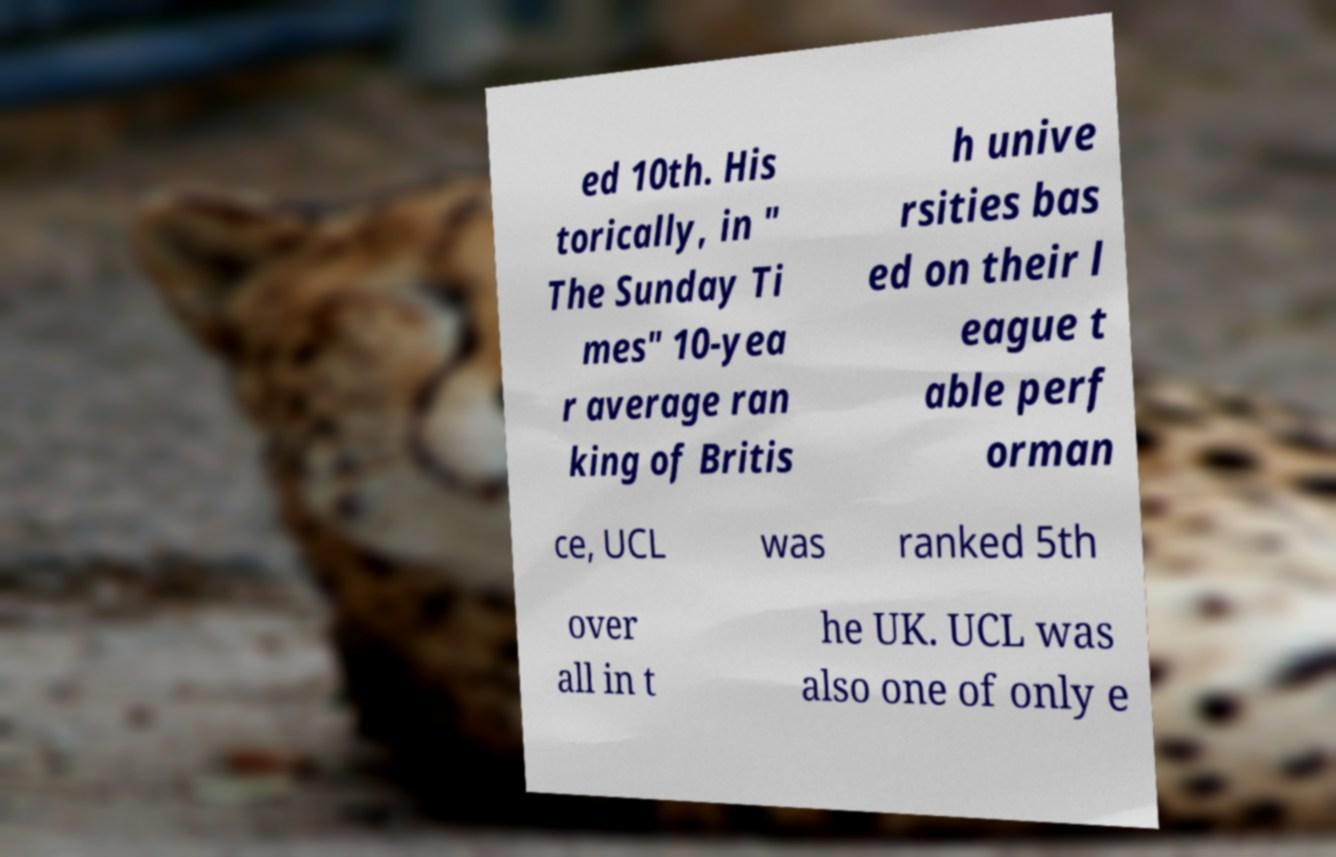Could you assist in decoding the text presented in this image and type it out clearly? ed 10th. His torically, in " The Sunday Ti mes" 10-yea r average ran king of Britis h unive rsities bas ed on their l eague t able perf orman ce, UCL was ranked 5th over all in t he UK. UCL was also one of only e 